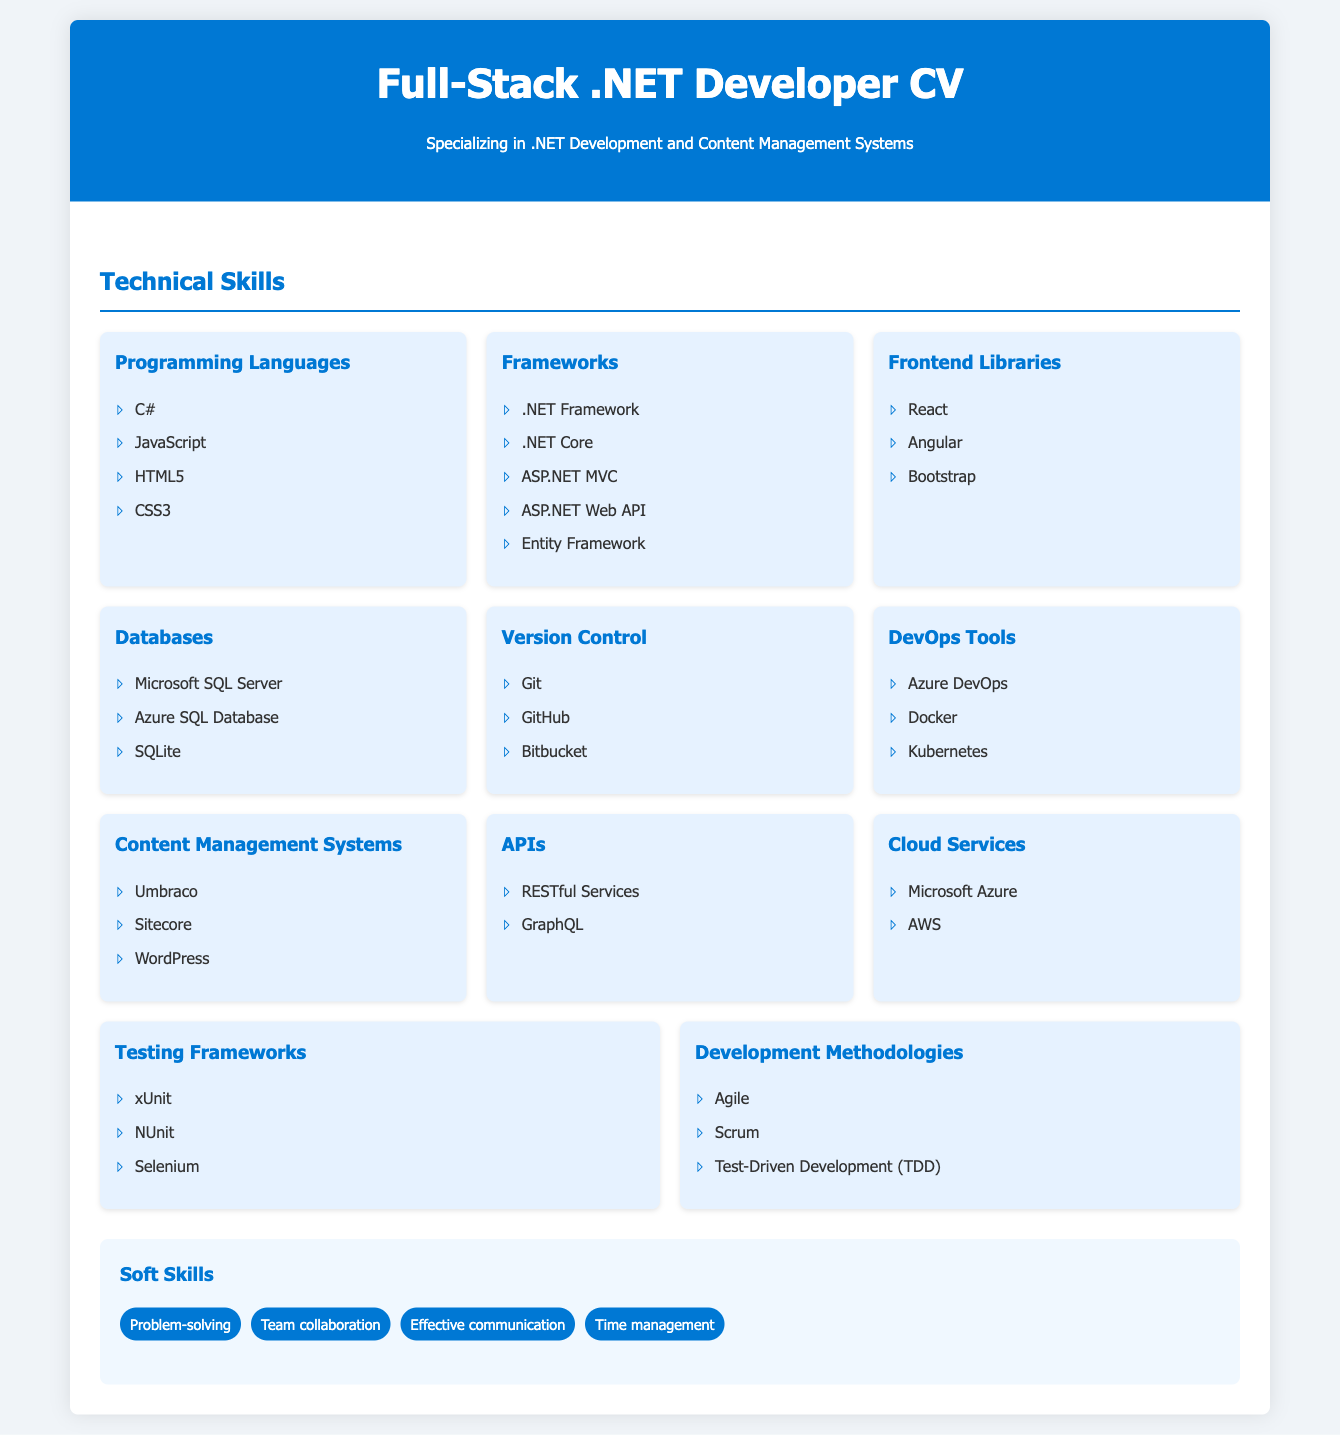what programming languages are mentioned? The document lists C#, JavaScript, HTML5, and CSS3 under Programming Languages.
Answer: C#, JavaScript, HTML5, CSS3 how many frameworks are listed? The document lists 5 frameworks under the Frameworks category.
Answer: 5 which content management systems are included? The document specifies Umbraco, Sitecore, and WordPress under Content Management Systems.
Answer: Umbraco, Sitecore, WordPress what testing frameworks does the CV feature? The CV mentions xUnit, NUnit, and Selenium under Testing Frameworks.
Answer: xUnit, NUnit, Selenium name one cloud service mentioned in the document. The document lists Microsoft Azure and AWS as Cloud Services.
Answer: Microsoft Azure which development methodologies are included? The CV features Agile, Scrum, and Test-Driven Development under Development Methodologies.
Answer: Agile, Scrum, Test-Driven Development what is the main focus of this CV? The CV emphasizes full-stack development with a specialization in .NET and CMS.
Answer: Full-Stack .NET Development how many soft skills are listed? The document lists 4 soft skills in the Soft Skills section.
Answer: 4 what are the frontend libraries mentioned? The CV lists React, Angular, and Bootstrap under Frontend Libraries.
Answer: React, Angular, Bootstrap 